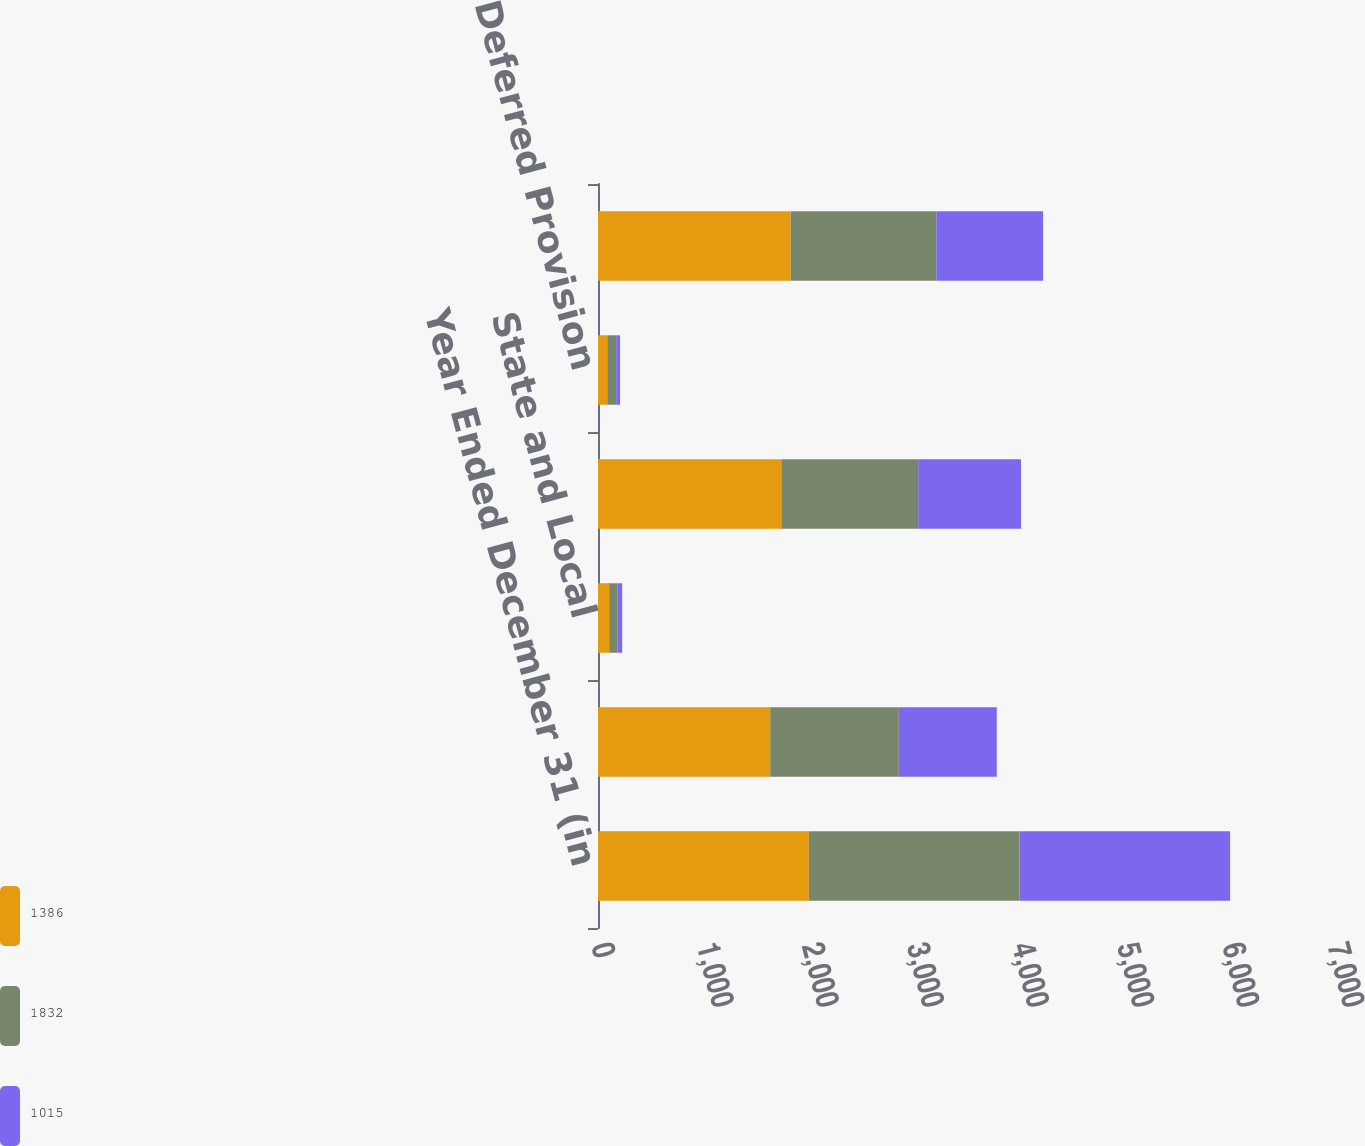Convert chart to OTSL. <chart><loc_0><loc_0><loc_500><loc_500><stacked_bar_chart><ecel><fcel>Year Ended December 31 (in<fcel>Federal<fcel>State and Local<fcel>Total Current Provision<fcel>Deferred Provision<fcel>Total Provision for Income<nl><fcel>1386<fcel>2005<fcel>1638<fcel>106<fcel>1744<fcel>88<fcel>1832<nl><fcel>1832<fcel>2004<fcel>1223<fcel>78<fcel>1301<fcel>85<fcel>1386<nl><fcel>1015<fcel>2003<fcel>932<fcel>46<fcel>978<fcel>37<fcel>1015<nl></chart> 